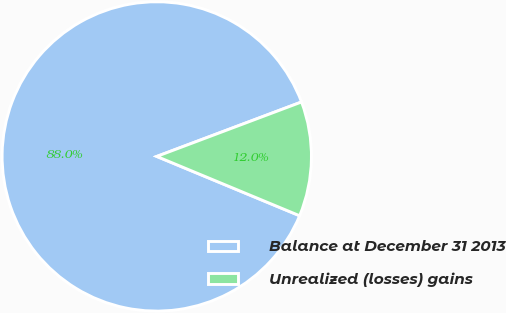Convert chart. <chart><loc_0><loc_0><loc_500><loc_500><pie_chart><fcel>Balance at December 31 2013<fcel>Unrealized (losses) gains<nl><fcel>88.01%<fcel>11.99%<nl></chart> 